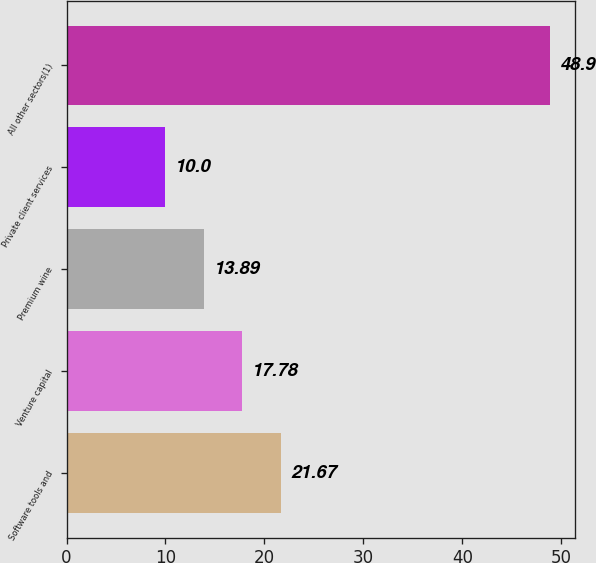Convert chart to OTSL. <chart><loc_0><loc_0><loc_500><loc_500><bar_chart><fcel>Software tools and<fcel>Venture capital<fcel>Premium wine<fcel>Private client services<fcel>All other sectors(1)<nl><fcel>21.67<fcel>17.78<fcel>13.89<fcel>10<fcel>48.9<nl></chart> 